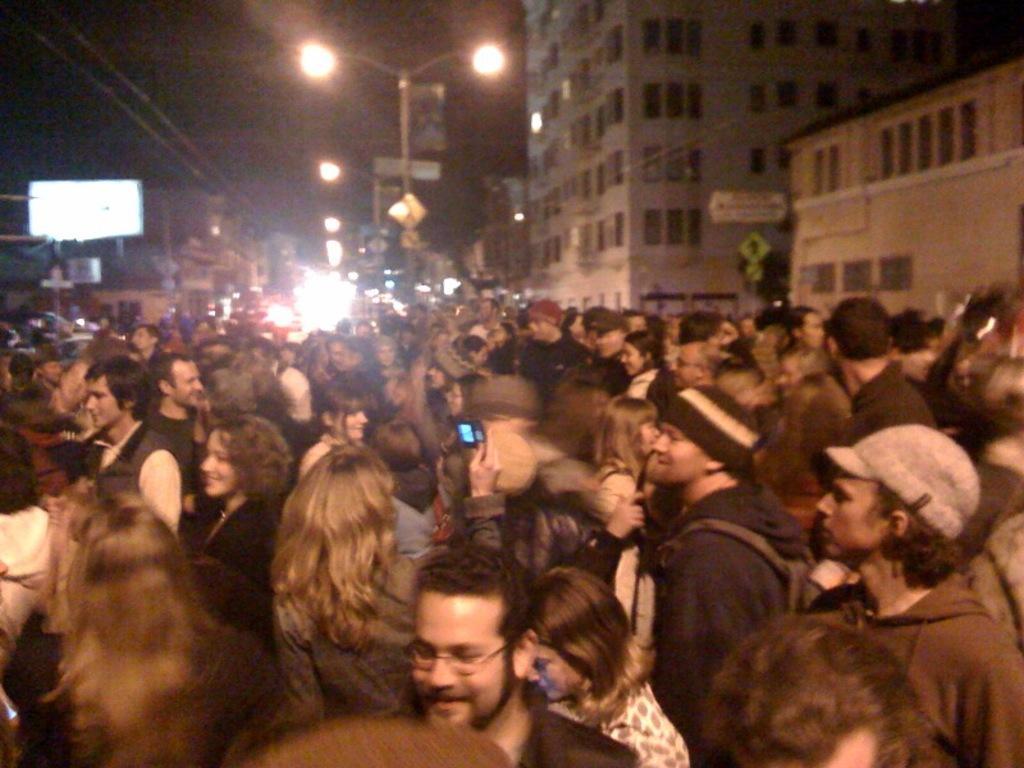Describe this image in one or two sentences. In this image we can see so many people are standing on the road. Background of the image street lights, wires and buildings are present. 